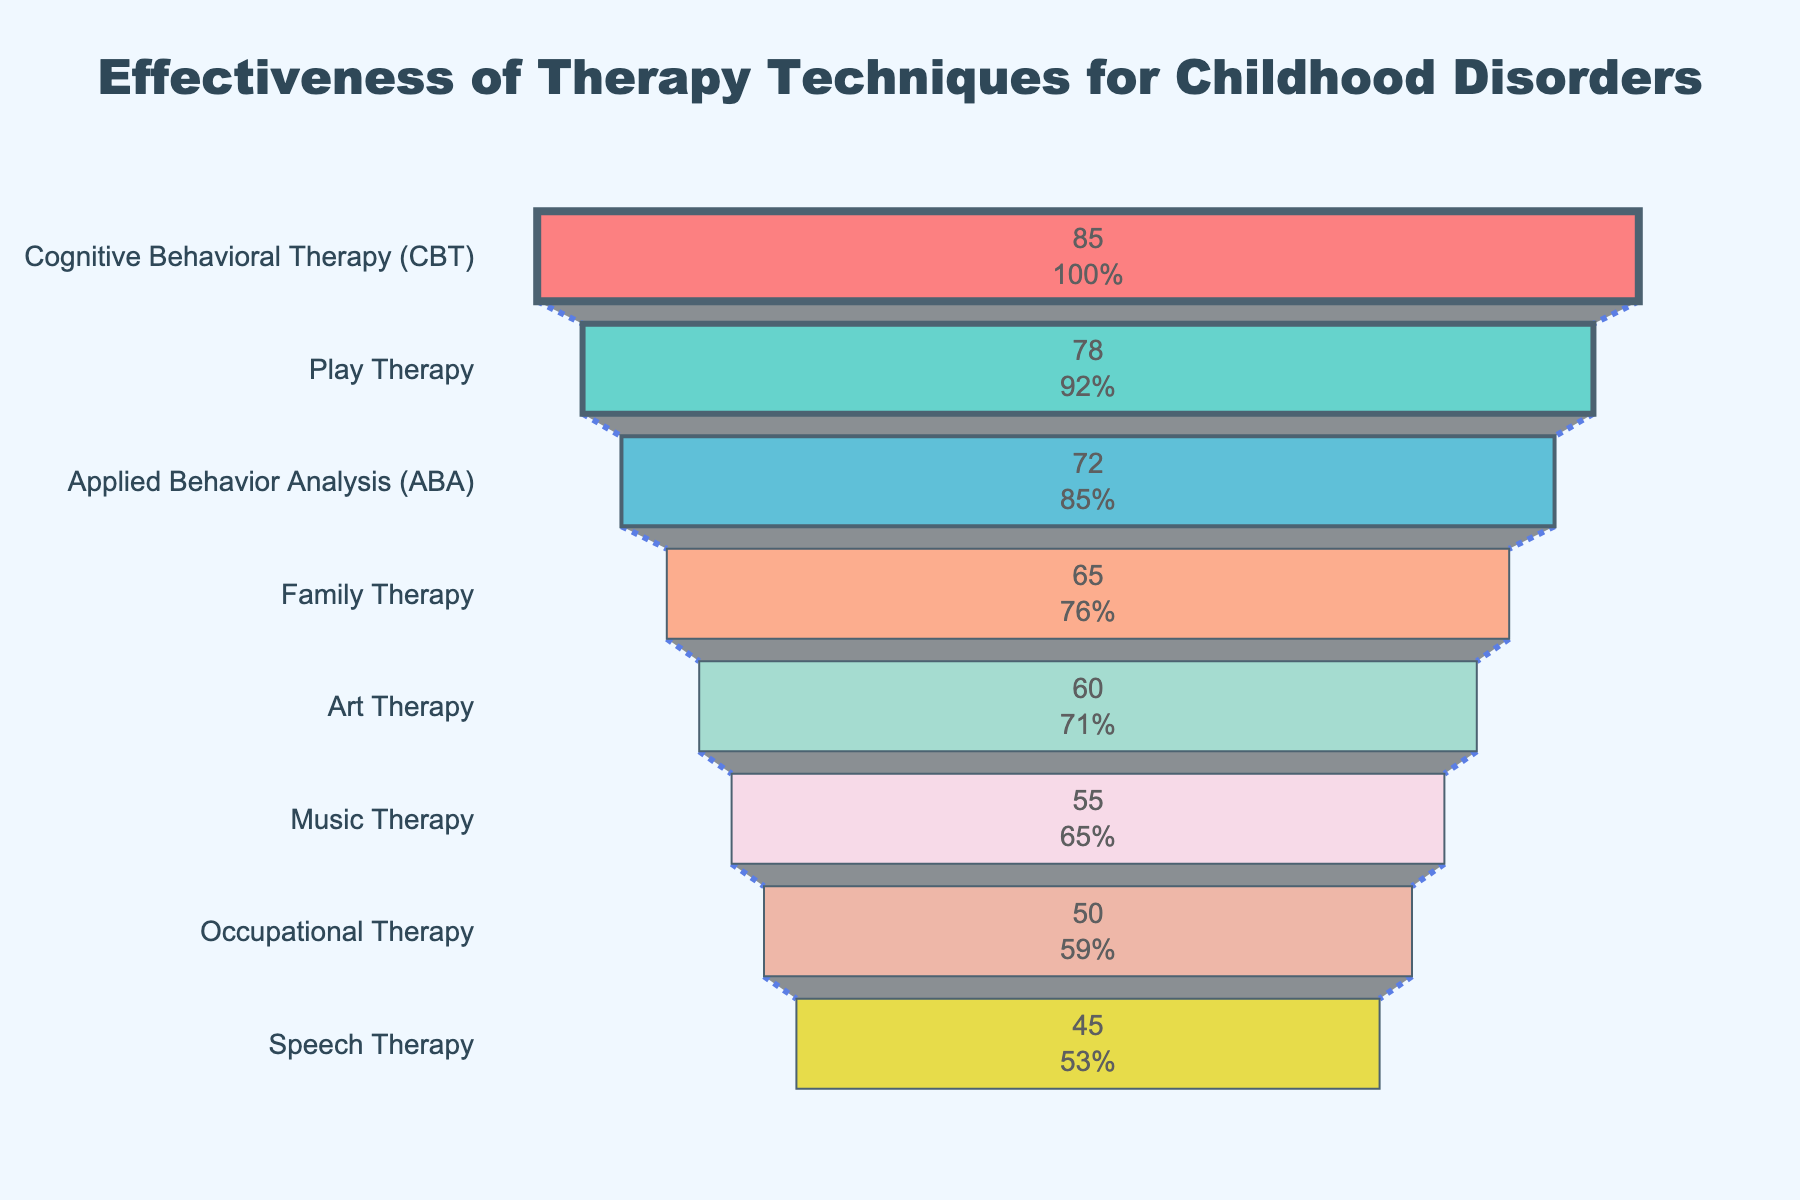What is the title of the funnel chart? The title of the funnel chart is typically found at the top of the chart and provides a summary of what the chart is about.
Answer: Effectiveness of Therapy Techniques for Childhood Disorders How many therapy techniques are displayed in the funnel chart? Count the different therapy techniques listed on the y-axis of the funnel chart.
Answer: 8 Which therapy technique has the highest effectiveness rate? Identify the top bar in the funnel chart, as the data is sorted in descending order of effectiveness.
Answer: Cognitive Behavioral Therapy (CBT) What is the effectiveness rate of Music Therapy? Look for Music Therapy in the funnel chart and read the corresponding effectiveness rate from the x-axis.
Answer: 55% Which therapy technique has an effectiveness rate of 60%? Locate the section on the funnel chart with an effectiveness rate of 60% and identify the corresponding therapy technique.
Answer: Art Therapy How does the effectiveness of Play Therapy compare to that of Family Therapy? Find the effectiveness rates of Play Therapy (78%) and Family Therapy (65%), then compare them.
Answer: Play Therapy is more effective than Family Therapy Calculate the average effectiveness rate of all therapy techniques. Add the effectiveness rates of all therapy techniques and divide by the number of techniques: (85 + 78 + 72 + 65 + 60 + 55 + 50 + 45) / 8
Answer: 63.75% What is the difference in effectiveness rate between the most effective and least effective therapy techniques? Subtract the effectiveness rate of the least effective technique (Speech Therapy - 45%) from the most effective technique (CBT - 85%).
Answer: 40% Which three therapy techniques have the highest effectiveness rates? Select the top three techniques from the funnel chart based on their effectiveness rates.
Answer: Cognitive Behavioral Therapy (CBT), Play Therapy, Applied Behavior Analysis (ABA) If you want to improve overall effectiveness rates, which three therapy techniques would you consider less effective based on this chart? Identify the three therapy techniques with the lowest effectiveness rates from the funnel chart.
Answer: Music Therapy, Occupational Therapy, Speech Therapy 